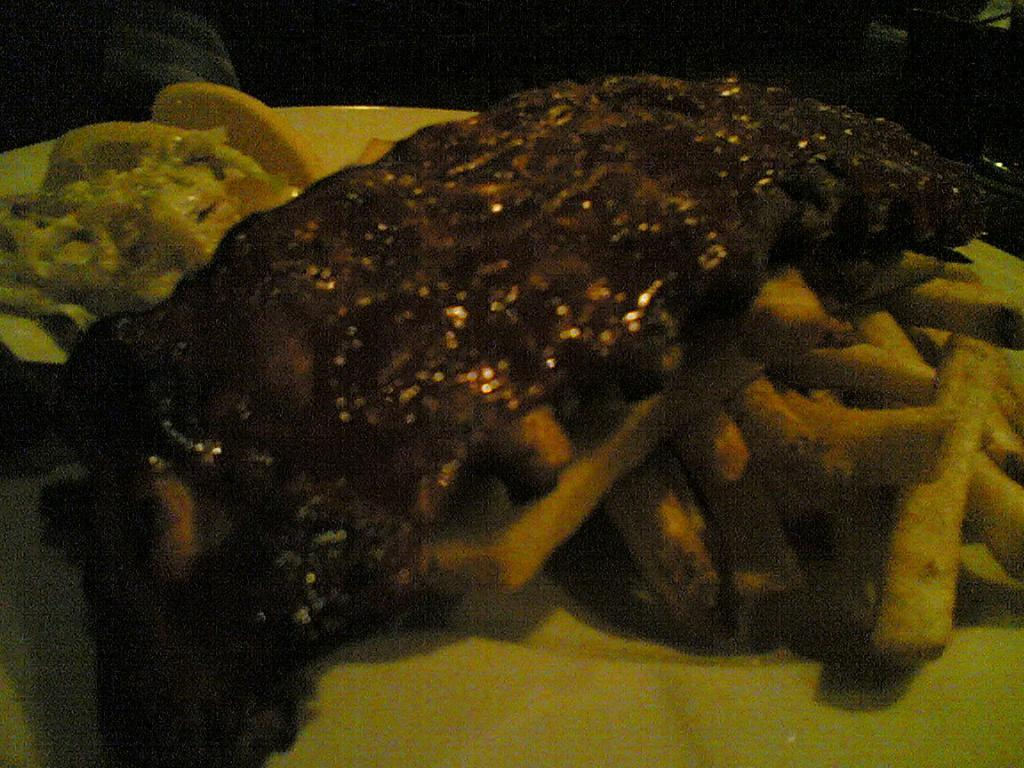What object is present on the plate in the image? There is a plate in the image. What is the color of the plate? The plate is green in color. What types of food can be seen on the plate? There is fried meat, vegetable fries, and salad on the plate. How many beds are visible in the image? There are no beds present in the image; it features a plate with food. What type of grain is being used to make the salad in the image? There is no indication of the type of grain used in the salad in the image. 